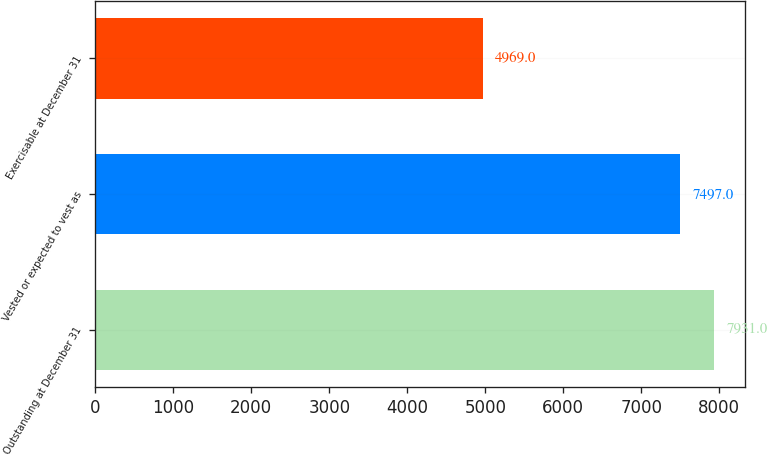Convert chart to OTSL. <chart><loc_0><loc_0><loc_500><loc_500><bar_chart><fcel>Outstanding at December 31<fcel>Vested or expected to vest as<fcel>Exercisable at December 31<nl><fcel>7931<fcel>7497<fcel>4969<nl></chart> 